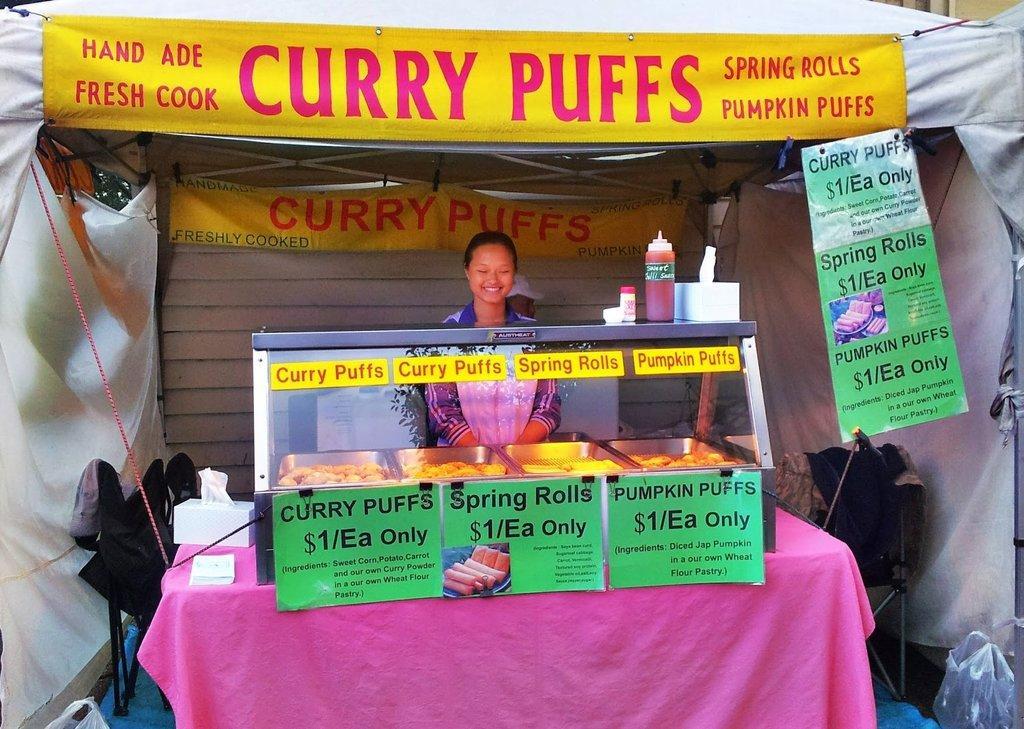How would you summarize this image in a sentence or two? In the center of the image, we can see a person standing and in the background, there is a shed and we can see banners, a stand, some food items, trays, cars, clothes and we can see a table and some other objects. 